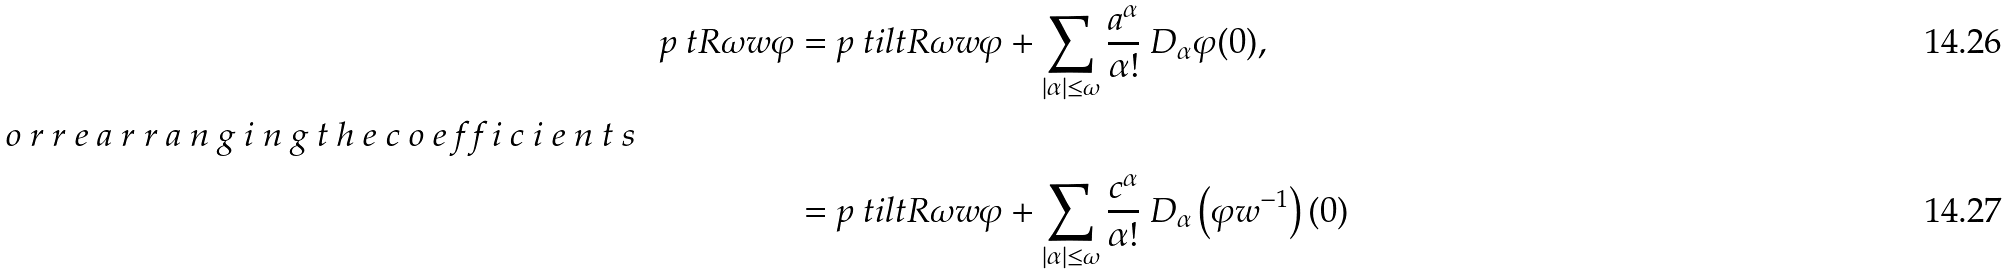Convert formula to latex. <formula><loc_0><loc_0><loc_500><loc_500>p { \ t R { \omega } { w } } { \varphi } & = p { \ t i l t R { \omega } { w } } { \varphi } + \sum _ { | \alpha | \leq \omega } \frac { a ^ { \alpha } } { \alpha ! } \ D _ { \alpha } \varphi ( 0 ) , \\ \intertext { o r r e a r r a n g i n g t h e c o e f f i c i e n t s } & = p { \ t i l t R { \omega } { w } } { \varphi } + \sum _ { | \alpha | \leq \omega } \frac { c ^ { \alpha } } { \alpha ! } \ D _ { \alpha } \left ( \varphi w ^ { - 1 } \right ) ( 0 )</formula> 